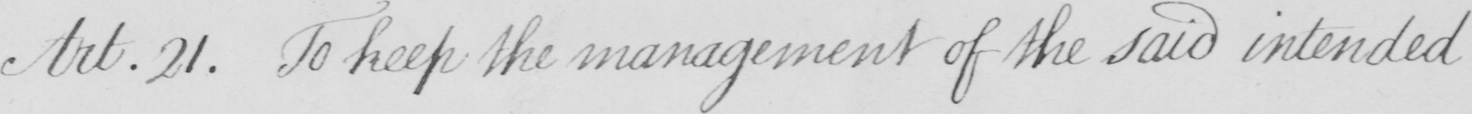Transcribe the text shown in this historical manuscript line. Art.21 . To keep the management of the said intended 